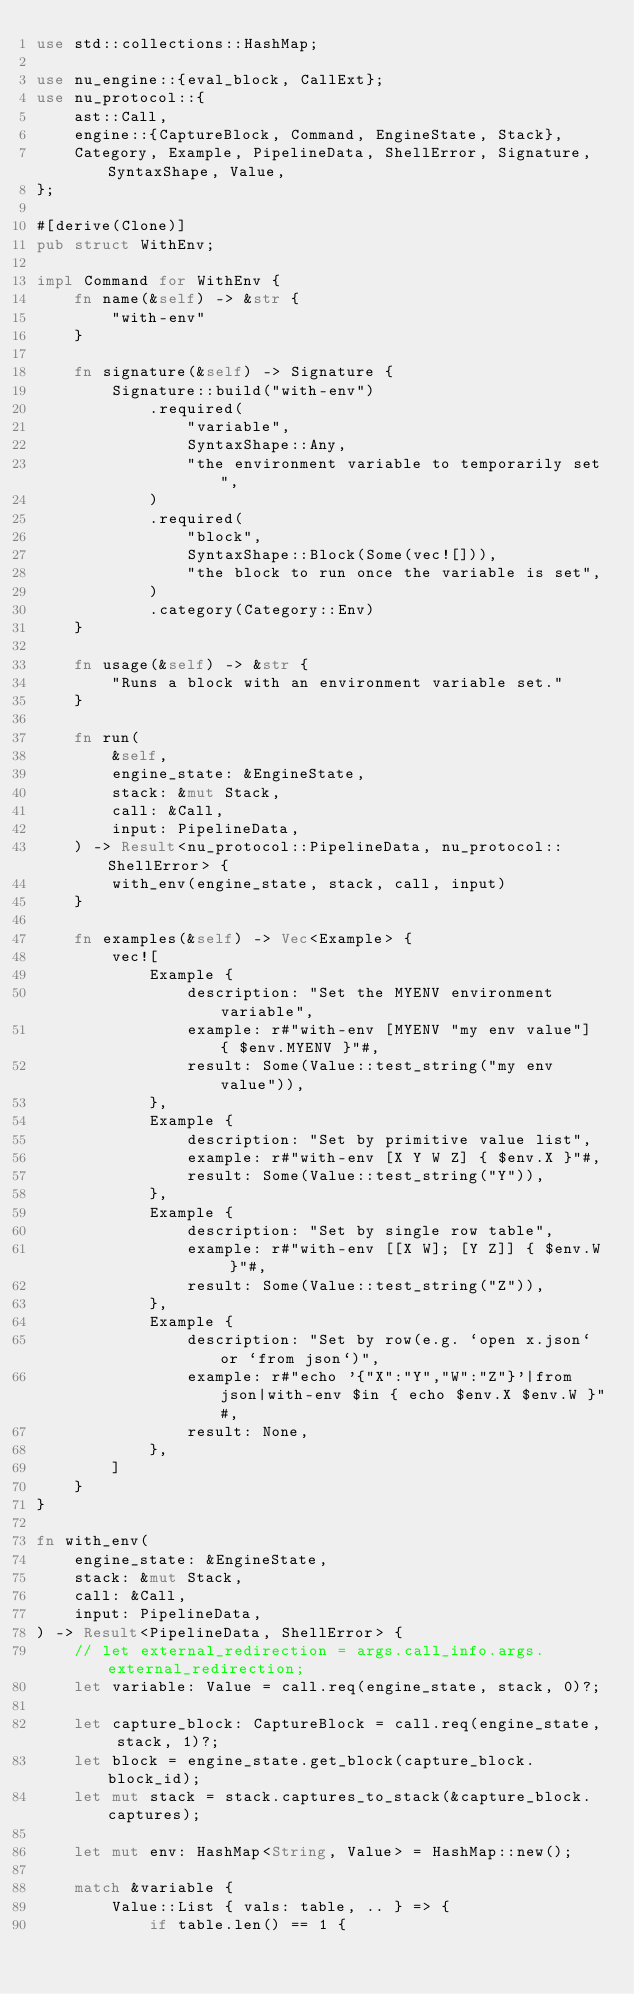<code> <loc_0><loc_0><loc_500><loc_500><_Rust_>use std::collections::HashMap;

use nu_engine::{eval_block, CallExt};
use nu_protocol::{
    ast::Call,
    engine::{CaptureBlock, Command, EngineState, Stack},
    Category, Example, PipelineData, ShellError, Signature, SyntaxShape, Value,
};

#[derive(Clone)]
pub struct WithEnv;

impl Command for WithEnv {
    fn name(&self) -> &str {
        "with-env"
    }

    fn signature(&self) -> Signature {
        Signature::build("with-env")
            .required(
                "variable",
                SyntaxShape::Any,
                "the environment variable to temporarily set",
            )
            .required(
                "block",
                SyntaxShape::Block(Some(vec![])),
                "the block to run once the variable is set",
            )
            .category(Category::Env)
    }

    fn usage(&self) -> &str {
        "Runs a block with an environment variable set."
    }

    fn run(
        &self,
        engine_state: &EngineState,
        stack: &mut Stack,
        call: &Call,
        input: PipelineData,
    ) -> Result<nu_protocol::PipelineData, nu_protocol::ShellError> {
        with_env(engine_state, stack, call, input)
    }

    fn examples(&self) -> Vec<Example> {
        vec![
            Example {
                description: "Set the MYENV environment variable",
                example: r#"with-env [MYENV "my env value"] { $env.MYENV }"#,
                result: Some(Value::test_string("my env value")),
            },
            Example {
                description: "Set by primitive value list",
                example: r#"with-env [X Y W Z] { $env.X }"#,
                result: Some(Value::test_string("Y")),
            },
            Example {
                description: "Set by single row table",
                example: r#"with-env [[X W]; [Y Z]] { $env.W }"#,
                result: Some(Value::test_string("Z")),
            },
            Example {
                description: "Set by row(e.g. `open x.json` or `from json`)",
                example: r#"echo '{"X":"Y","W":"Z"}'|from json|with-env $in { echo $env.X $env.W }"#,
                result: None,
            },
        ]
    }
}

fn with_env(
    engine_state: &EngineState,
    stack: &mut Stack,
    call: &Call,
    input: PipelineData,
) -> Result<PipelineData, ShellError> {
    // let external_redirection = args.call_info.args.external_redirection;
    let variable: Value = call.req(engine_state, stack, 0)?;

    let capture_block: CaptureBlock = call.req(engine_state, stack, 1)?;
    let block = engine_state.get_block(capture_block.block_id);
    let mut stack = stack.captures_to_stack(&capture_block.captures);

    let mut env: HashMap<String, Value> = HashMap::new();

    match &variable {
        Value::List { vals: table, .. } => {
            if table.len() == 1 {</code> 